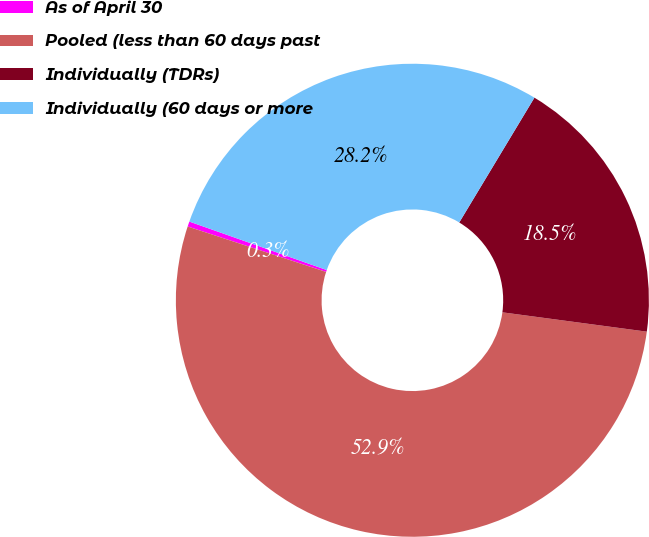<chart> <loc_0><loc_0><loc_500><loc_500><pie_chart><fcel>As of April 30<fcel>Pooled (less than 60 days past<fcel>Individually (TDRs)<fcel>Individually (60 days or more<nl><fcel>0.35%<fcel>52.93%<fcel>18.49%<fcel>28.23%<nl></chart> 